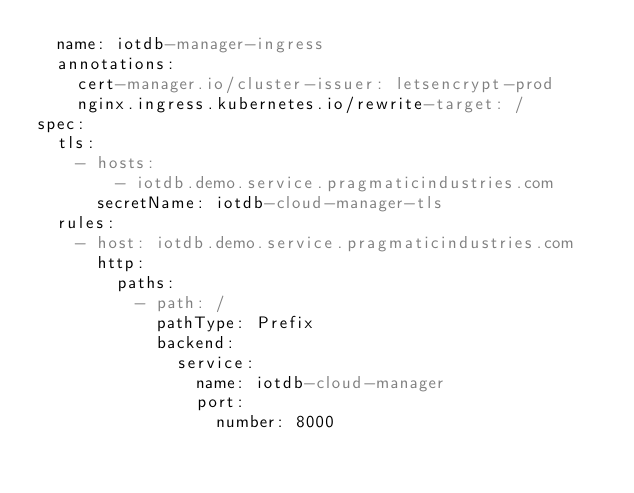<code> <loc_0><loc_0><loc_500><loc_500><_YAML_>  name: iotdb-manager-ingress
  annotations:
    cert-manager.io/cluster-issuer: letsencrypt-prod
    nginx.ingress.kubernetes.io/rewrite-target: /
spec:
  tls:
    - hosts:
        - iotdb.demo.service.pragmaticindustries.com
      secretName: iotdb-cloud-manager-tls
  rules:
    - host: iotdb.demo.service.pragmaticindustries.com
      http:
        paths:
          - path: /
            pathType: Prefix
            backend:
              service:
                name: iotdb-cloud-manager
                port:
                  number: 8000</code> 